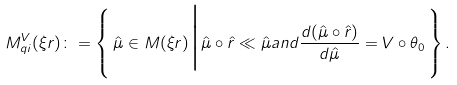<formula> <loc_0><loc_0><loc_500><loc_500>M _ { q i } ^ { V } ( \xi r ) \colon = \left \{ \, \hat { \mu } \in M ( \xi r ) \Big | \hat { \mu } \circ \hat { r } \ll \hat { \mu } a n d \frac { d ( \hat { \mu } \circ \hat { r } ) } { d \hat { \mu } } = V \circ \theta _ { 0 } \, \right \} .</formula> 